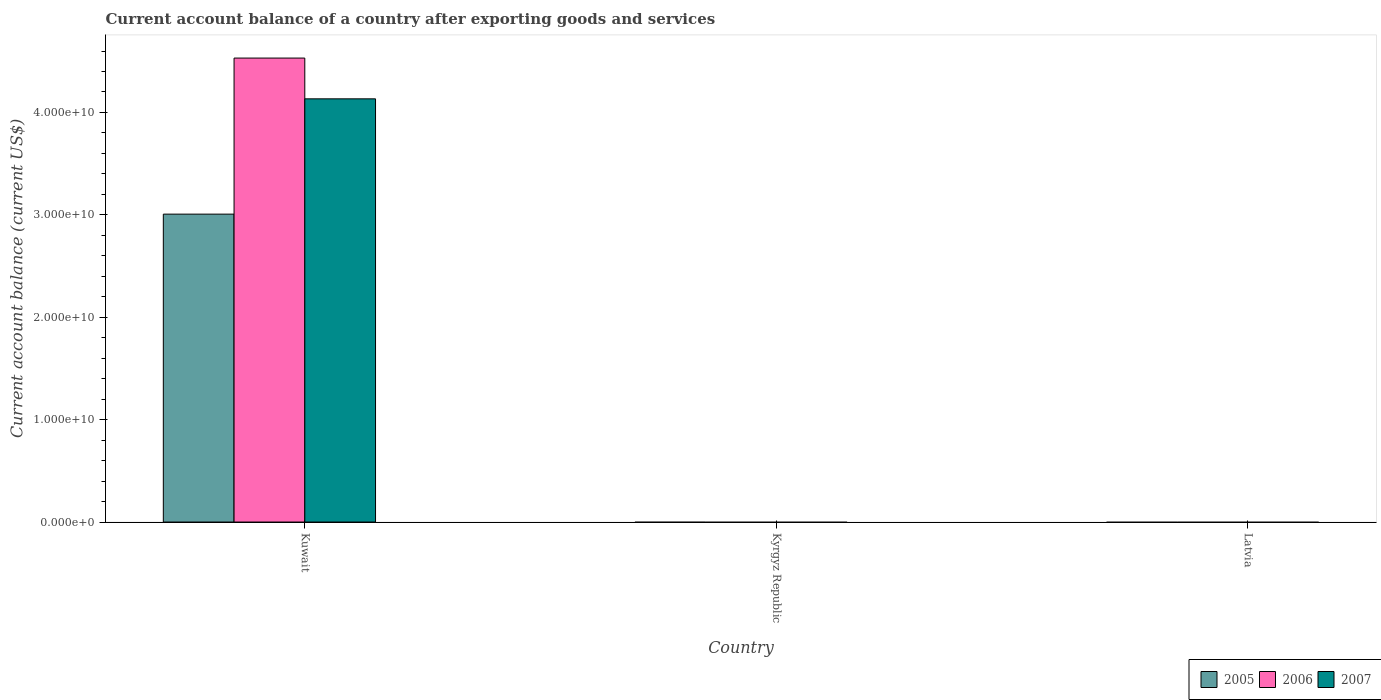How many bars are there on the 3rd tick from the right?
Offer a very short reply. 3. What is the label of the 3rd group of bars from the left?
Keep it short and to the point. Latvia. Across all countries, what is the maximum account balance in 2005?
Your response must be concise. 3.01e+1. Across all countries, what is the minimum account balance in 2006?
Offer a terse response. 0. In which country was the account balance in 2005 maximum?
Provide a short and direct response. Kuwait. What is the total account balance in 2005 in the graph?
Your answer should be very brief. 3.01e+1. What is the difference between the account balance in 2005 in Kuwait and the account balance in 2006 in Latvia?
Offer a very short reply. 3.01e+1. What is the average account balance in 2007 per country?
Ensure brevity in your answer.  1.38e+1. What is the difference between the account balance of/in 2007 and account balance of/in 2006 in Kuwait?
Provide a short and direct response. -3.98e+09. What is the difference between the highest and the lowest account balance in 2006?
Your response must be concise. 4.53e+1. Is it the case that in every country, the sum of the account balance in 2005 and account balance in 2007 is greater than the account balance in 2006?
Your response must be concise. No. How many bars are there?
Your answer should be very brief. 3. What is the difference between two consecutive major ticks on the Y-axis?
Offer a terse response. 1.00e+1. Are the values on the major ticks of Y-axis written in scientific E-notation?
Give a very brief answer. Yes. How many legend labels are there?
Your answer should be compact. 3. How are the legend labels stacked?
Keep it short and to the point. Horizontal. What is the title of the graph?
Make the answer very short. Current account balance of a country after exporting goods and services. Does "1992" appear as one of the legend labels in the graph?
Offer a terse response. No. What is the label or title of the X-axis?
Your answer should be very brief. Country. What is the label or title of the Y-axis?
Make the answer very short. Current account balance (current US$). What is the Current account balance (current US$) of 2005 in Kuwait?
Provide a succinct answer. 3.01e+1. What is the Current account balance (current US$) of 2006 in Kuwait?
Offer a terse response. 4.53e+1. What is the Current account balance (current US$) in 2007 in Kuwait?
Your response must be concise. 4.13e+1. What is the Current account balance (current US$) of 2007 in Kyrgyz Republic?
Ensure brevity in your answer.  0. What is the Current account balance (current US$) of 2005 in Latvia?
Keep it short and to the point. 0. What is the Current account balance (current US$) of 2006 in Latvia?
Provide a short and direct response. 0. Across all countries, what is the maximum Current account balance (current US$) in 2005?
Provide a short and direct response. 3.01e+1. Across all countries, what is the maximum Current account balance (current US$) in 2006?
Make the answer very short. 4.53e+1. Across all countries, what is the maximum Current account balance (current US$) of 2007?
Offer a very short reply. 4.13e+1. Across all countries, what is the minimum Current account balance (current US$) in 2005?
Offer a very short reply. 0. Across all countries, what is the minimum Current account balance (current US$) of 2006?
Your answer should be compact. 0. What is the total Current account balance (current US$) of 2005 in the graph?
Your response must be concise. 3.01e+1. What is the total Current account balance (current US$) in 2006 in the graph?
Provide a short and direct response. 4.53e+1. What is the total Current account balance (current US$) of 2007 in the graph?
Offer a very short reply. 4.13e+1. What is the average Current account balance (current US$) of 2005 per country?
Make the answer very short. 1.00e+1. What is the average Current account balance (current US$) in 2006 per country?
Ensure brevity in your answer.  1.51e+1. What is the average Current account balance (current US$) of 2007 per country?
Offer a very short reply. 1.38e+1. What is the difference between the Current account balance (current US$) in 2005 and Current account balance (current US$) in 2006 in Kuwait?
Your response must be concise. -1.52e+1. What is the difference between the Current account balance (current US$) of 2005 and Current account balance (current US$) of 2007 in Kuwait?
Offer a very short reply. -1.13e+1. What is the difference between the Current account balance (current US$) in 2006 and Current account balance (current US$) in 2007 in Kuwait?
Your answer should be very brief. 3.98e+09. What is the difference between the highest and the lowest Current account balance (current US$) in 2005?
Make the answer very short. 3.01e+1. What is the difference between the highest and the lowest Current account balance (current US$) in 2006?
Your answer should be very brief. 4.53e+1. What is the difference between the highest and the lowest Current account balance (current US$) of 2007?
Make the answer very short. 4.13e+1. 